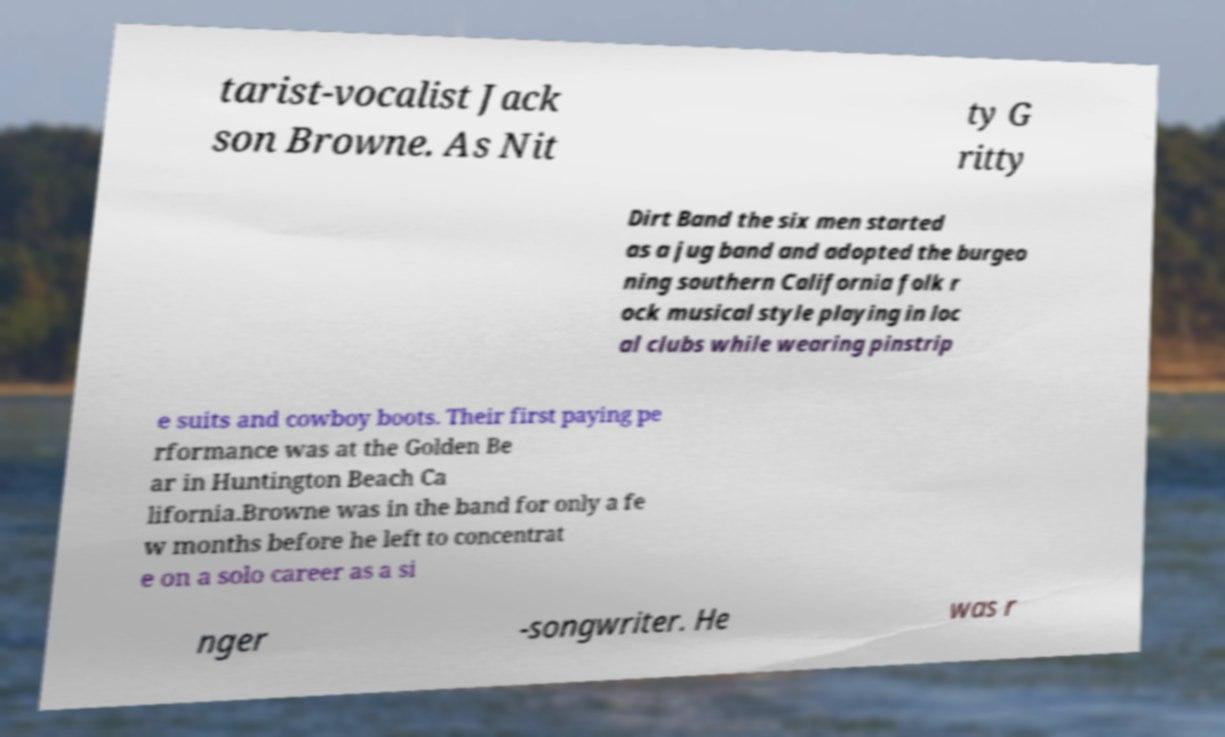Can you read and provide the text displayed in the image?This photo seems to have some interesting text. Can you extract and type it out for me? tarist-vocalist Jack son Browne. As Nit ty G ritty Dirt Band the six men started as a jug band and adopted the burgeo ning southern California folk r ock musical style playing in loc al clubs while wearing pinstrip e suits and cowboy boots. Their first paying pe rformance was at the Golden Be ar in Huntington Beach Ca lifornia.Browne was in the band for only a fe w months before he left to concentrat e on a solo career as a si nger -songwriter. He was r 